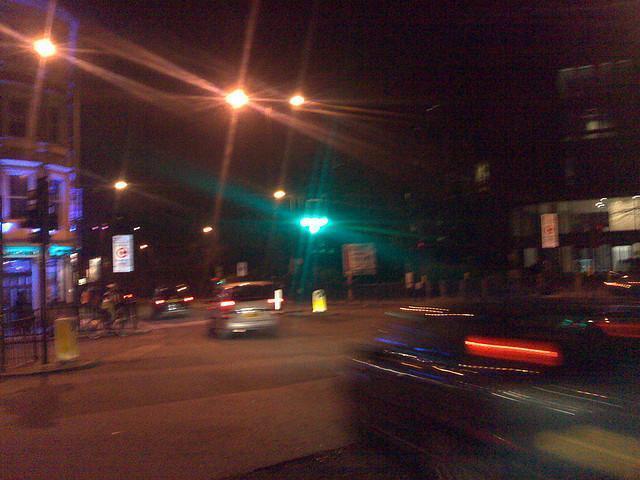How many cars are visible?
Give a very brief answer. 2. How many clocks are on the bottom half of the building?
Give a very brief answer. 0. 